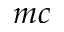<formula> <loc_0><loc_0><loc_500><loc_500>m c</formula> 